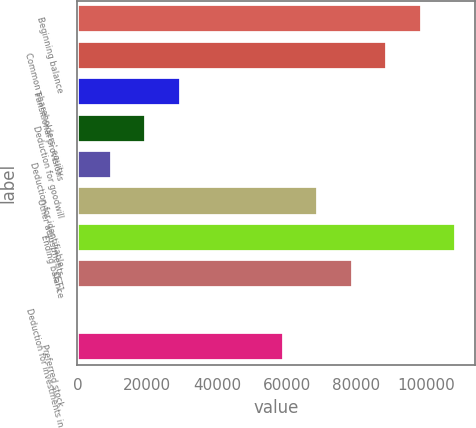<chart> <loc_0><loc_0><loc_500><loc_500><bar_chart><fcel>Beginning balance<fcel>Common shareholders' equity<fcel>Transitional provisions<fcel>Deduction for goodwill<fcel>Deduction for identifiable<fcel>Other adjustments<fcel>Ending balance<fcel>CET1<fcel>Deduction for investments in<fcel>Preferred stock<nl><fcel>98628<fcel>88767.7<fcel>29605.9<fcel>19745.6<fcel>9885.3<fcel>69047.1<fcel>108488<fcel>78907.4<fcel>25<fcel>59186.8<nl></chart> 